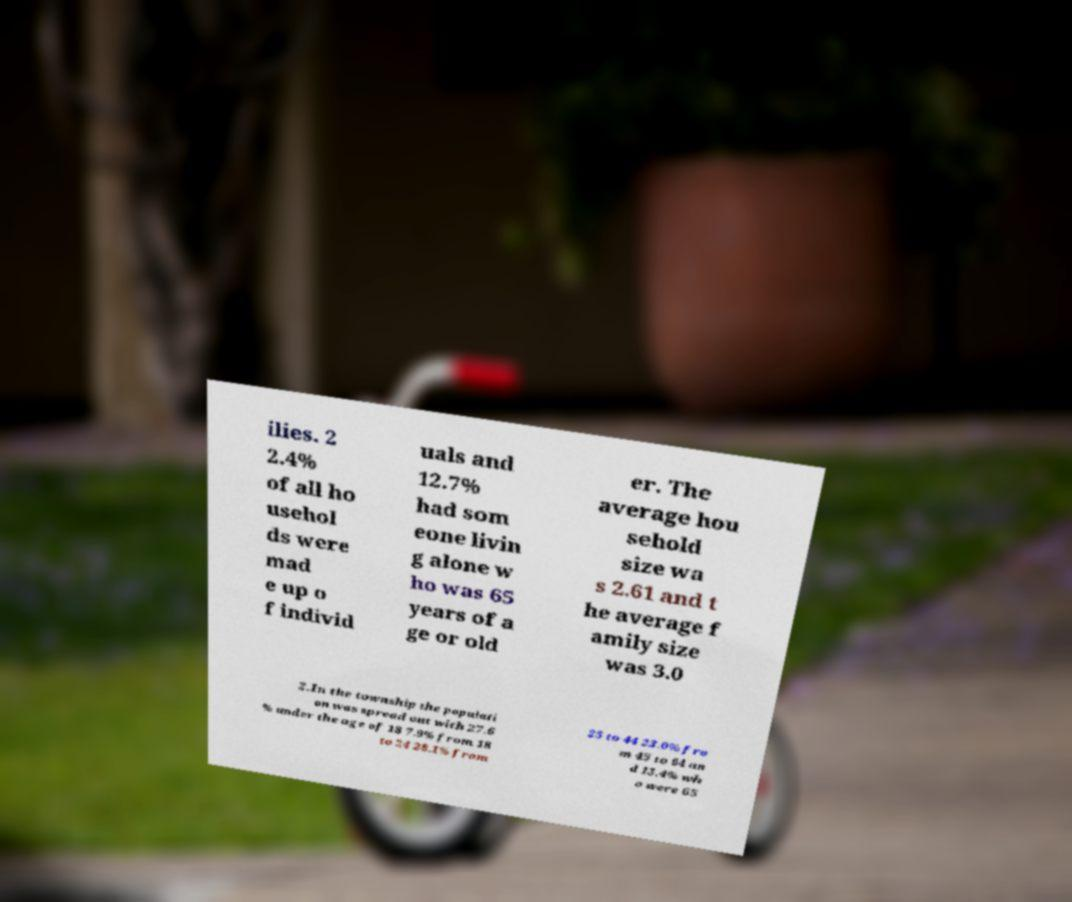Please read and relay the text visible in this image. What does it say? ilies. 2 2.4% of all ho usehol ds were mad e up o f individ uals and 12.7% had som eone livin g alone w ho was 65 years of a ge or old er. The average hou sehold size wa s 2.61 and t he average f amily size was 3.0 2.In the township the populati on was spread out with 27.6 % under the age of 18 7.9% from 18 to 24 28.1% from 25 to 44 23.0% fro m 45 to 64 an d 13.4% wh o were 65 